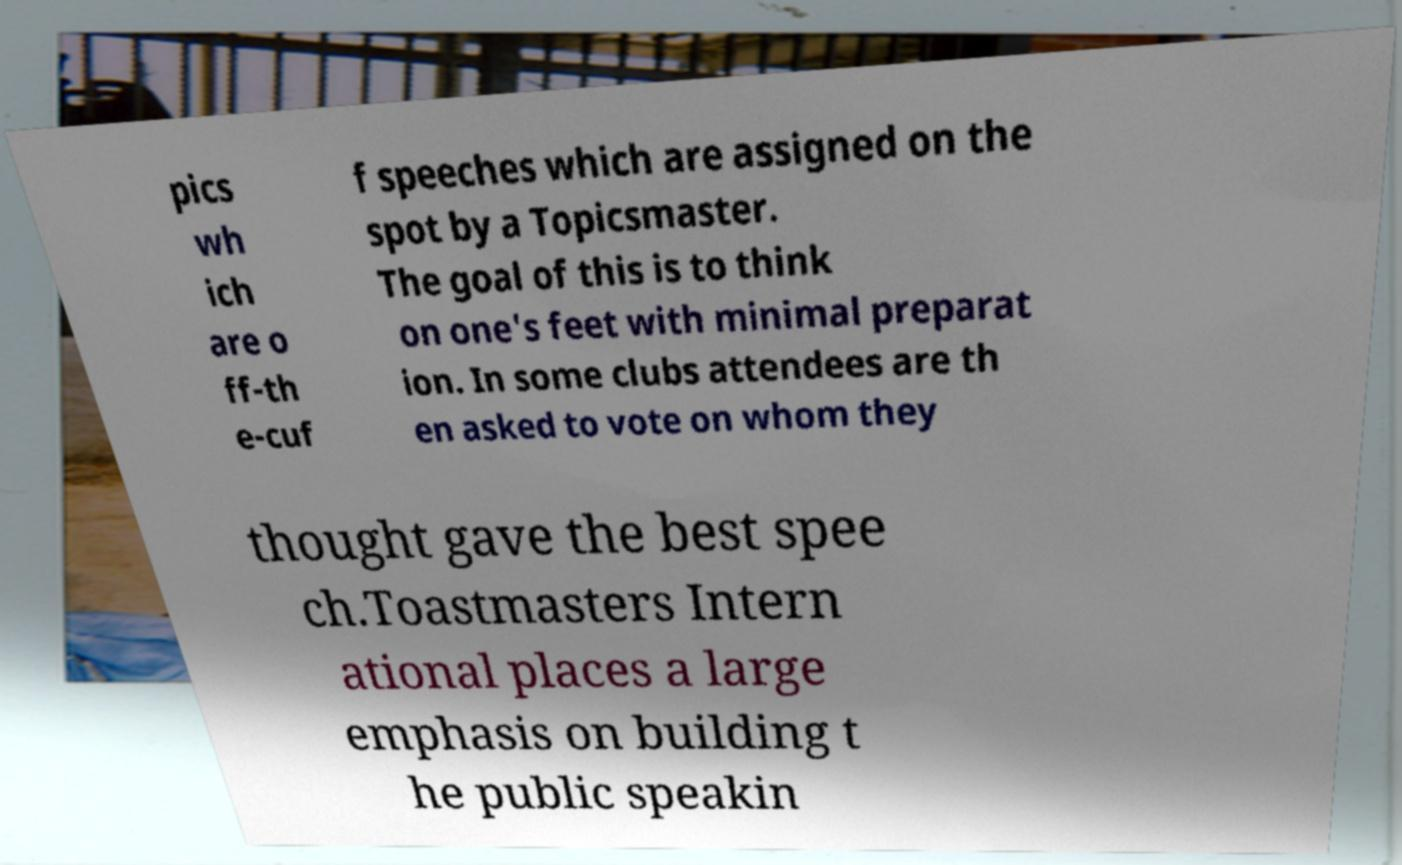Please identify and transcribe the text found in this image. pics wh ich are o ff-th e-cuf f speeches which are assigned on the spot by a Topicsmaster. The goal of this is to think on one's feet with minimal preparat ion. In some clubs attendees are th en asked to vote on whom they thought gave the best spee ch.Toastmasters Intern ational places a large emphasis on building t he public speakin 